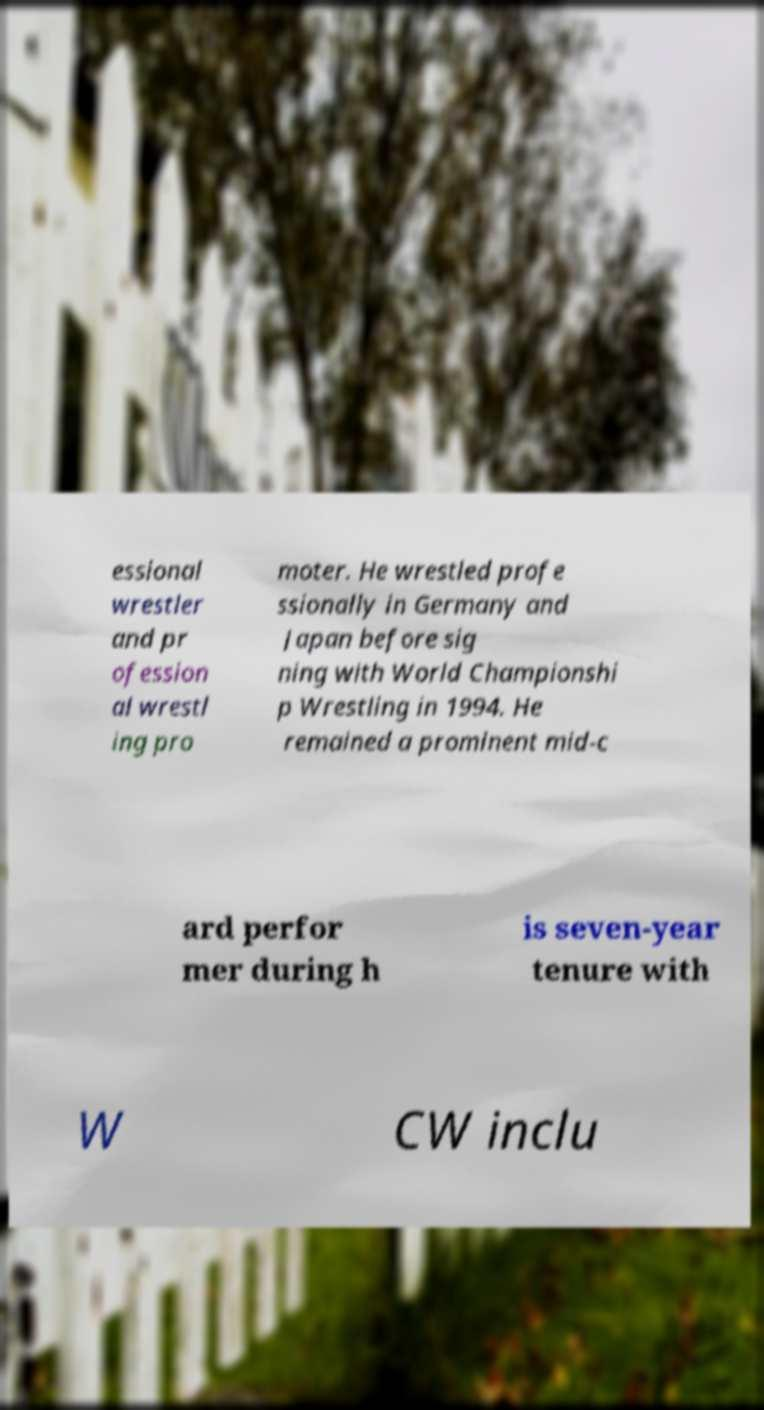Could you extract and type out the text from this image? essional wrestler and pr ofession al wrestl ing pro moter. He wrestled profe ssionally in Germany and Japan before sig ning with World Championshi p Wrestling in 1994. He remained a prominent mid-c ard perfor mer during h is seven-year tenure with W CW inclu 